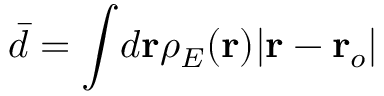<formula> <loc_0><loc_0><loc_500><loc_500>\bar { d } = \int \, d r \rho _ { E } ( r ) | r - r _ { o } |</formula> 